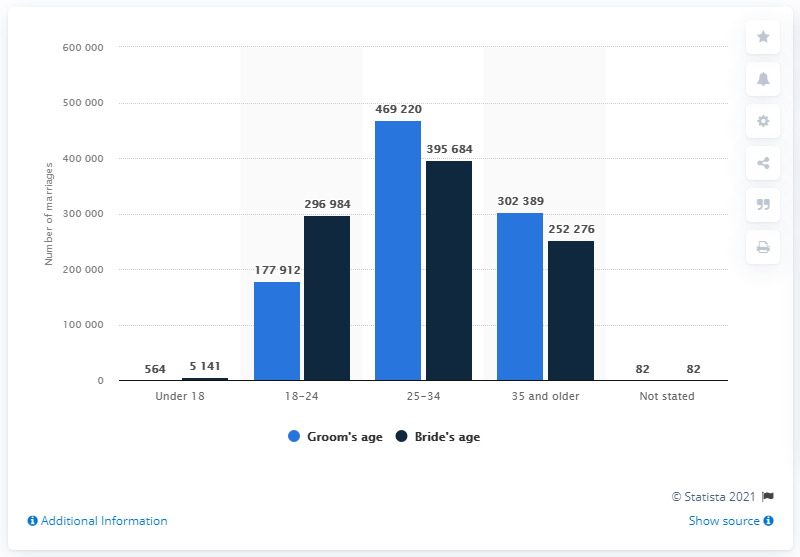List a handful of essential elements in this visual. In 2019, there were 395,684 marriages recorded in Russia where the bride was between the age of 25 and 34. In 2019, a total of 469,220 marriages were registered in Russia, with a groom being present in each of them. There were 5,141 brides under the age of 18 in Russia in 2019. 